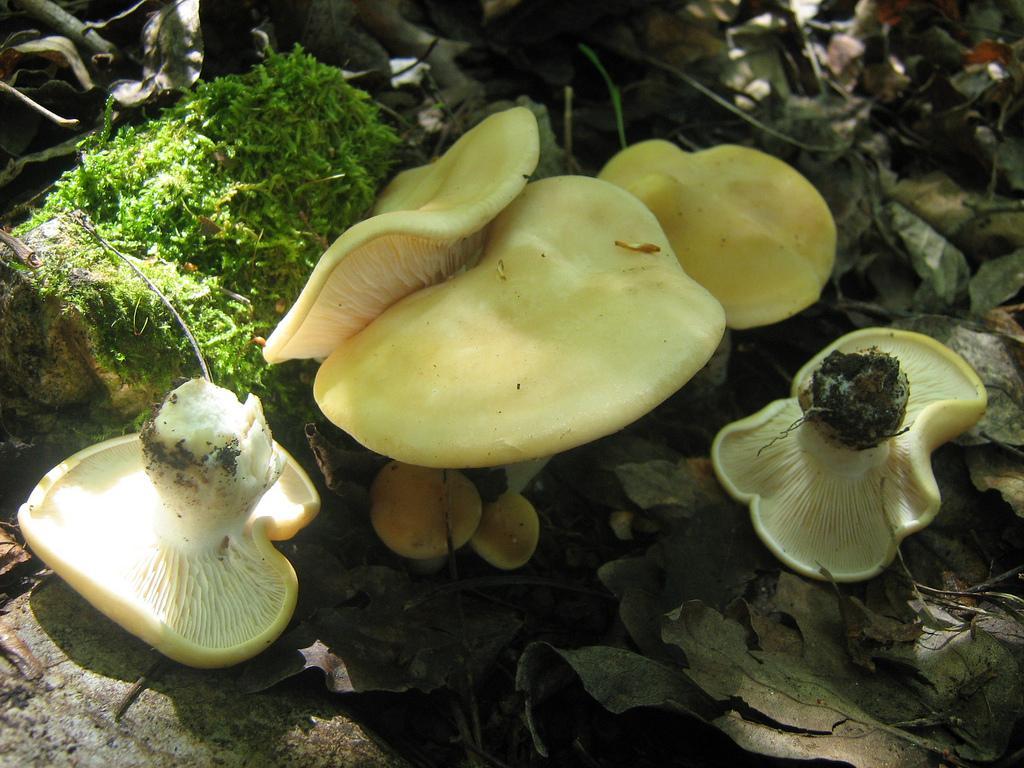Describe this image in one or two sentences. In this image at front there are mushrooms and at the bottom there are some dried leaves. We can also see a plant. 